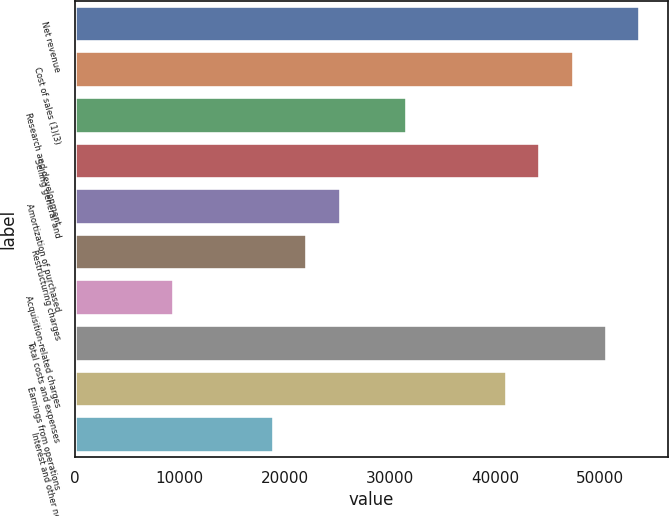<chart> <loc_0><loc_0><loc_500><loc_500><bar_chart><fcel>Net revenue<fcel>Cost of sales (1)(3)<fcel>Research and development<fcel>Selling general and<fcel>Amortization of purchased<fcel>Restructuring charges<fcel>Acquisition-related charges<fcel>Total costs and expenses<fcel>Earnings from operations<fcel>Interest and other net<nl><fcel>53774.3<fcel>47447.9<fcel>31632<fcel>44284.7<fcel>25305.6<fcel>22142.4<fcel>9489.65<fcel>50611.1<fcel>41121.6<fcel>18979.2<nl></chart> 